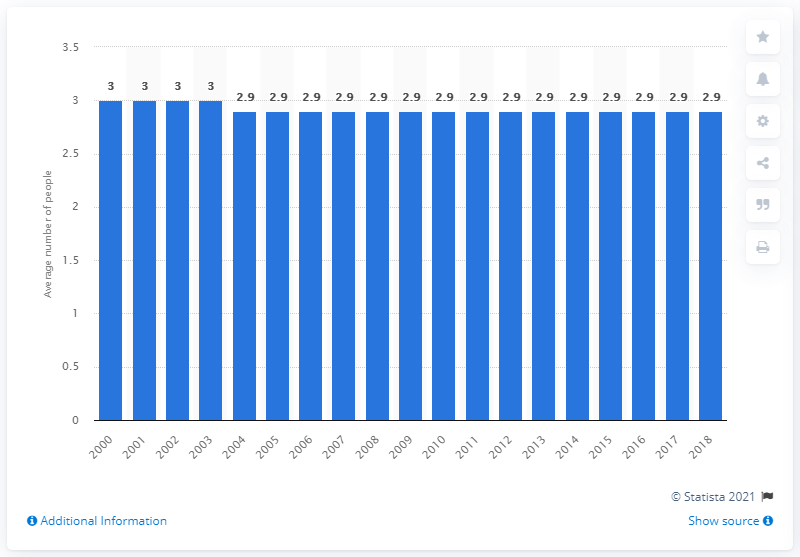Outline some significant characteristics in this image. In 2018, the average household in Canada consisted of 2.9 people. In 2000, the average number of people in a Canadian household was approximately three. 